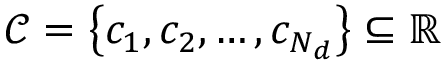<formula> <loc_0><loc_0><loc_500><loc_500>\mathcal { C } = \left \{ c _ { 1 } , c _ { 2 } , \dots c , c _ { N _ { d } } \right \} \subseteq \mathbb { R }</formula> 